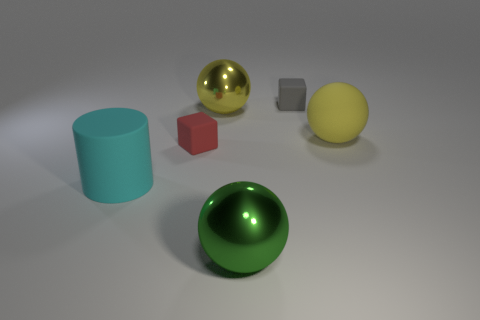What number of things are either yellow rubber balls or small red metal cylinders?
Offer a terse response. 1. There is a tiny matte thing to the right of the green thing; are there any big green metal things behind it?
Keep it short and to the point. No. Are there more matte cubes that are to the right of the big yellow shiny object than large things to the right of the yellow rubber object?
Your answer should be very brief. Yes. What material is the other ball that is the same color as the big matte sphere?
Offer a terse response. Metal. What number of shiny spheres have the same color as the large matte ball?
Give a very brief answer. 1. Is the color of the tiny cube to the left of the small gray matte thing the same as the rubber object that is behind the rubber sphere?
Provide a short and direct response. No. There is a gray block; are there any large green balls on the right side of it?
Your answer should be very brief. No. What material is the big cyan cylinder?
Give a very brief answer. Rubber. What is the shape of the thing right of the tiny gray matte cube?
Provide a short and direct response. Sphere. The shiny object that is the same color as the rubber ball is what size?
Your answer should be very brief. Large. 